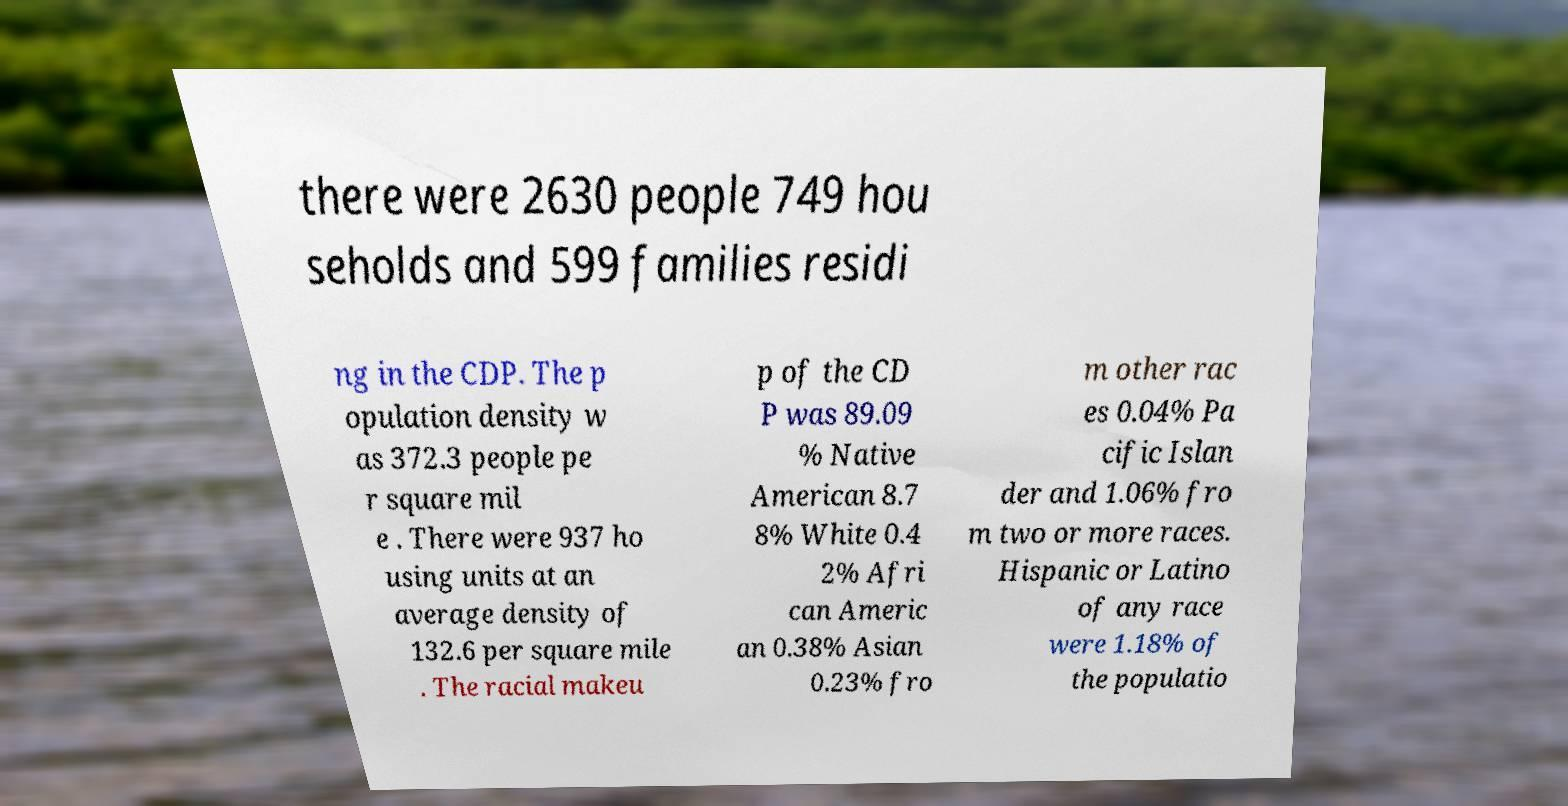Can you accurately transcribe the text from the provided image for me? there were 2630 people 749 hou seholds and 599 families residi ng in the CDP. The p opulation density w as 372.3 people pe r square mil e . There were 937 ho using units at an average density of 132.6 per square mile . The racial makeu p of the CD P was 89.09 % Native American 8.7 8% White 0.4 2% Afri can Americ an 0.38% Asian 0.23% fro m other rac es 0.04% Pa cific Islan der and 1.06% fro m two or more races. Hispanic or Latino of any race were 1.18% of the populatio 